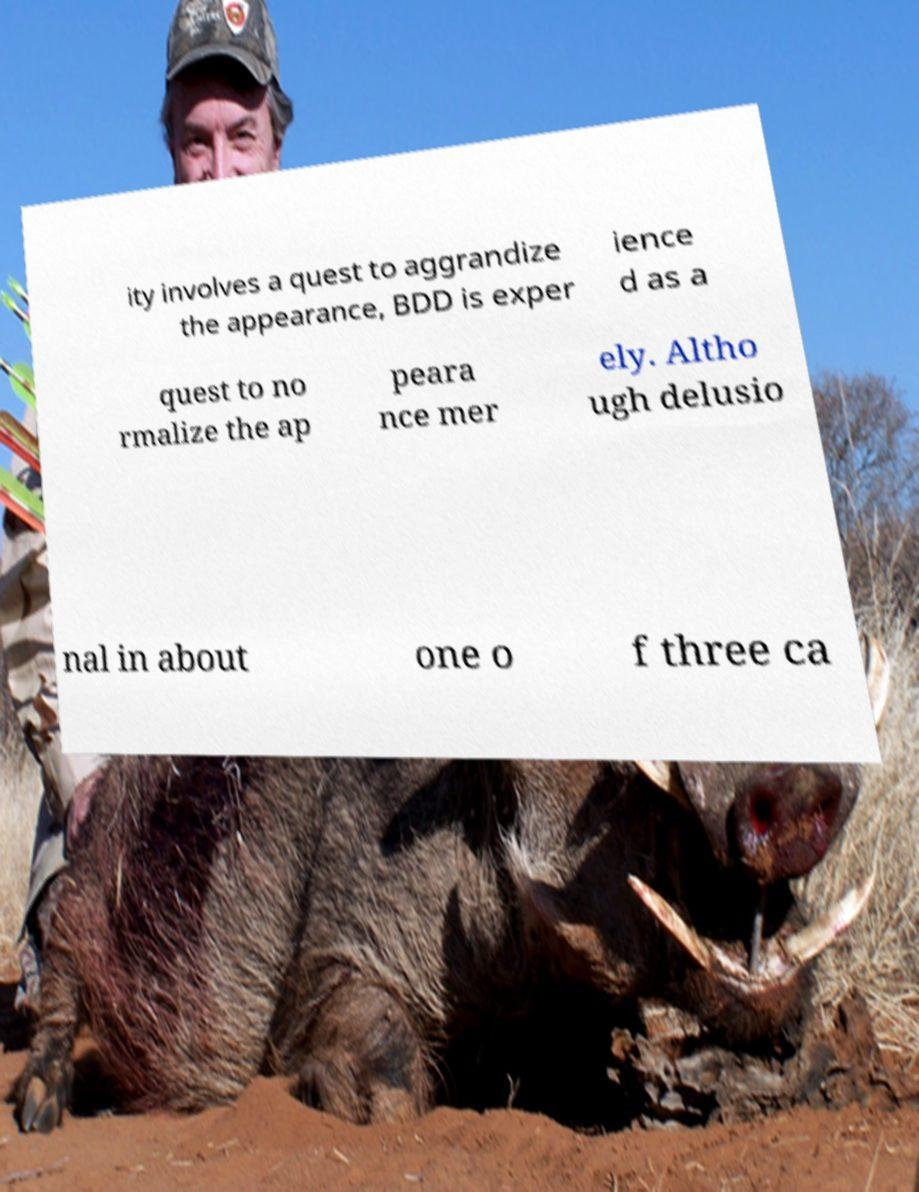Please identify and transcribe the text found in this image. ity involves a quest to aggrandize the appearance, BDD is exper ience d as a quest to no rmalize the ap peara nce mer ely. Altho ugh delusio nal in about one o f three ca 